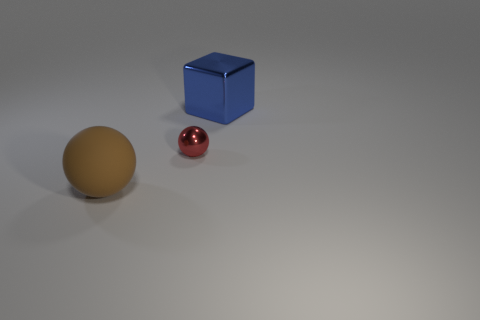Add 3 big brown matte balls. How many objects exist? 6 Subtract all brown spheres. How many spheres are left? 1 Subtract 1 balls. How many balls are left? 1 Subtract all brown blocks. How many yellow spheres are left? 0 Add 2 large purple metallic balls. How many large purple metallic balls exist? 2 Subtract 0 yellow cylinders. How many objects are left? 3 Subtract all cubes. How many objects are left? 2 Subtract all gray spheres. Subtract all green cubes. How many spheres are left? 2 Subtract all big things. Subtract all blue metallic cylinders. How many objects are left? 1 Add 3 big balls. How many big balls are left? 4 